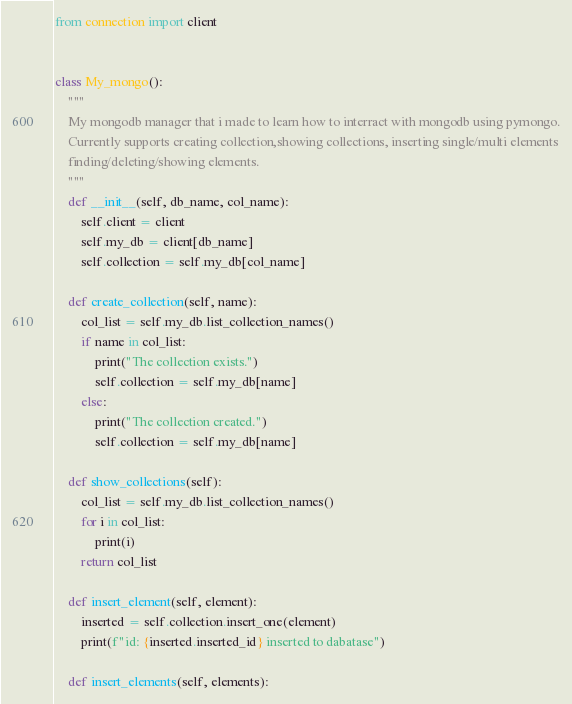<code> <loc_0><loc_0><loc_500><loc_500><_Python_>from connection import client


class My_mongo():
    """
    My mongodb manager that i made to learn how to interract with mongodb using pymongo.
    Currently supports creating collection,showing collections, inserting single/multi elements
    finding/deleting/showing elements. 
    """
    def __init__(self, db_name, col_name):
        self.client = client
        self.my_db = client[db_name]
        self.collection = self.my_db[col_name]

    def create_collection(self, name):
        col_list = self.my_db.list_collection_names()
        if name in col_list:
            print("The collection exists.")
            self.collection = self.my_db[name]
        else:
            print("The collection created.")
            self.collection = self.my_db[name]

    def show_collections(self):
        col_list = self.my_db.list_collection_names()
        for i in col_list:
            print(i)
        return col_list

    def insert_element(self, element):
        inserted = self.collection.insert_one(element)
        print(f"id: {inserted.inserted_id} inserted to dabatase")

    def insert_elements(self, elements):</code> 